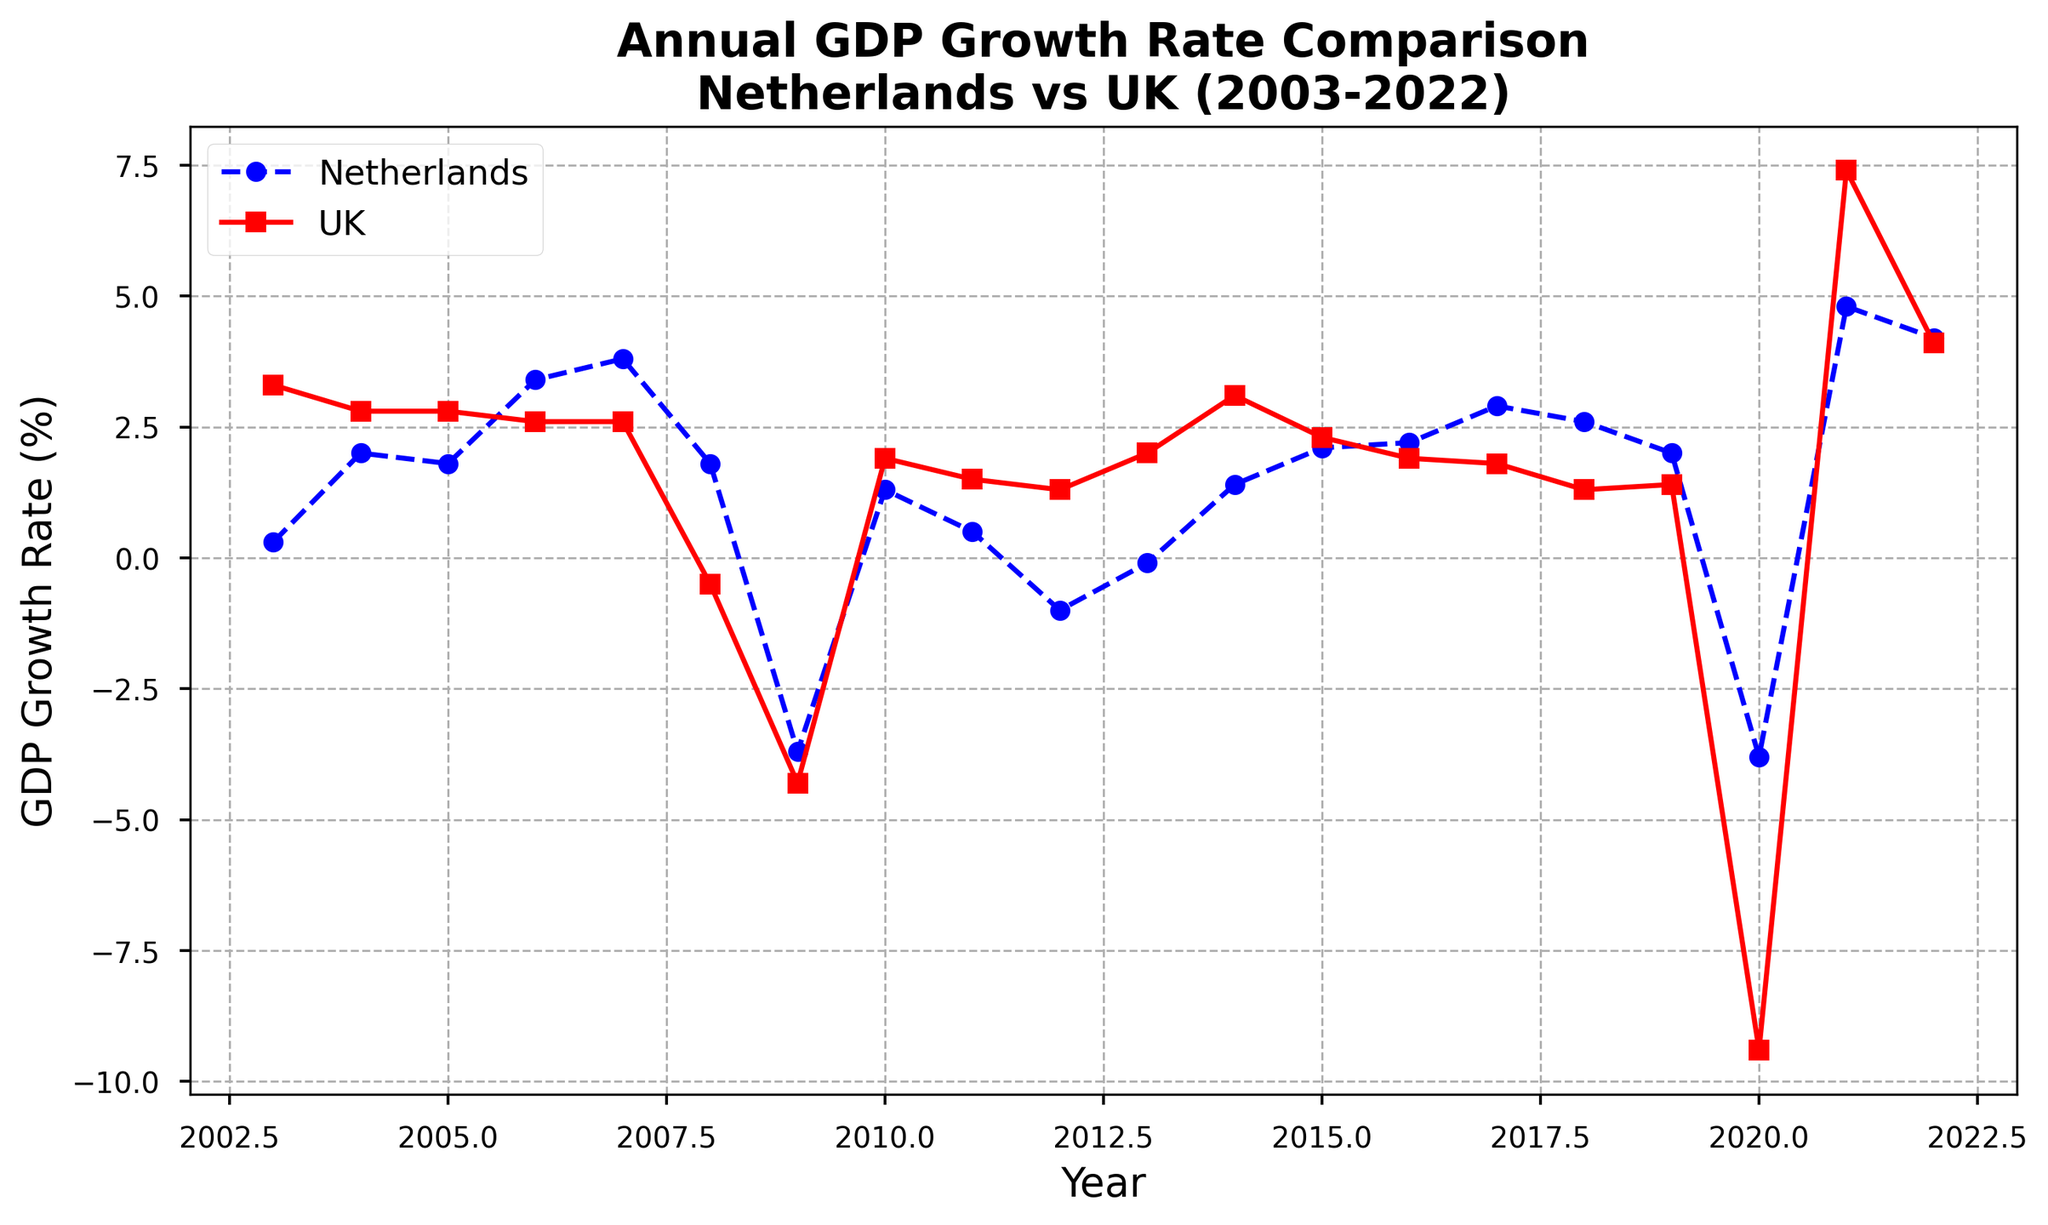What was the GDP growth rate difference between the Netherlands and the UK in 2020? The GDP growth rate for the Netherlands in 2020 was -3.8%, and for the UK, it was -9.4%. The difference is -3.8% - (-9.4%) = -3.8% + 9.4% = 5.6%.
Answer: 5.6% In which year did both countries experience a negative GDP growth rate? From the figure, both countries had negative GDP growth rates in 2009 and 2020.
Answer: 2009 and 2020 Which country had a higher GDP growth rate in 2014? In 2014, the GDP growth rate for the Netherlands was 1.4% and for the UK, it was 3.1%. Thus, the UK had a higher GDP growth rate in 2014.
Answer: UK Which country's GDP growth rate recovered faster after the 2009 dip, as judged by the 2010 growth rates? The Netherlands had a GDP growth rate of 1.3% in 2010, whereas the UK had a GDP growth rate of 1.9%. The UK recovered faster after the 2009 dip.
Answer: UK How many times did the Netherlands' GDP growth rate surpass 3% between 2003 and 2022? The Netherlands' GDP growth rate surpassed 3% in the years 2006, 2007, 2021, and 2022. That's a total of 4 occurrences.
Answer: 4 times During which years did the GDP growth rate of the Netherlands exceed that of the UK? The Netherlands' GDP growth rate exceeded the UK in the years 2006, 2007, 2008, 2016, 2017, 2018, 2019, 2020, and 2022.
Answer: 2006, 2007, 2008, 2016, 2017, 2018, 2019, 2020, 2022 What was the GDP growth rate trend for the Netherlands from 2018 to 2020? The GDP growth rate for the Netherlands decreased from 2.6% in 2018 to 2.0% in 2019, and then sharply dropped to -3.8% in 2020.
Answer: Decreasing trend What was the highest GDP growth rate achieved by the UK between 2003 and 2022, and in which year? The highest GDP growth rate for the UK during this period was 7.4%, achieved in the year 2021.
Answer: 7.4% in 2021 